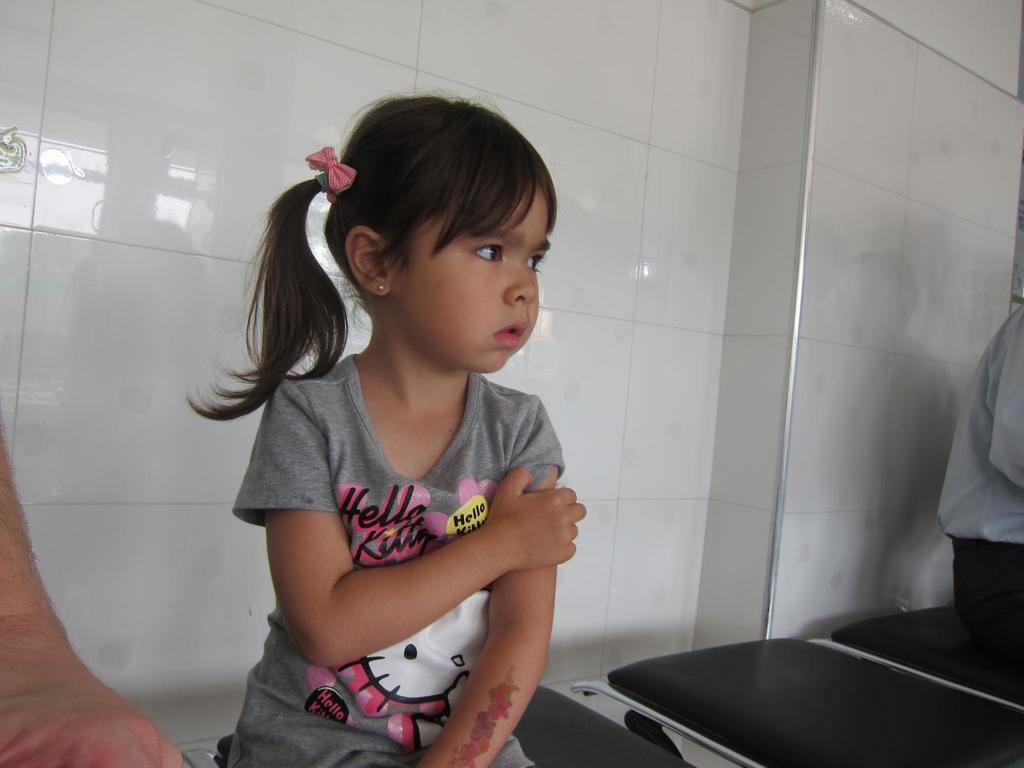Please provide a concise description of this image. In this picture we can see few people, they are all seated on the chairs, in the background we can see a wall. 